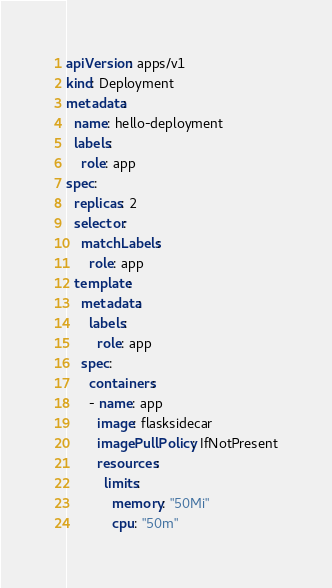<code> <loc_0><loc_0><loc_500><loc_500><_YAML_>apiVersion: apps/v1
kind: Deployment
metadata:
  name: hello-deployment
  labels:
    role: app
spec:
  replicas: 2
  selector:
    matchLabels:
      role: app    
  template:
    metadata:
      labels:
        role: app
    spec:
      containers:
      - name: app
        image: flasksidecar
        imagePullPolicy: IfNotPresent
        resources:
          limits:
            memory: "50Mi"
            cpu: "50m"
</code> 